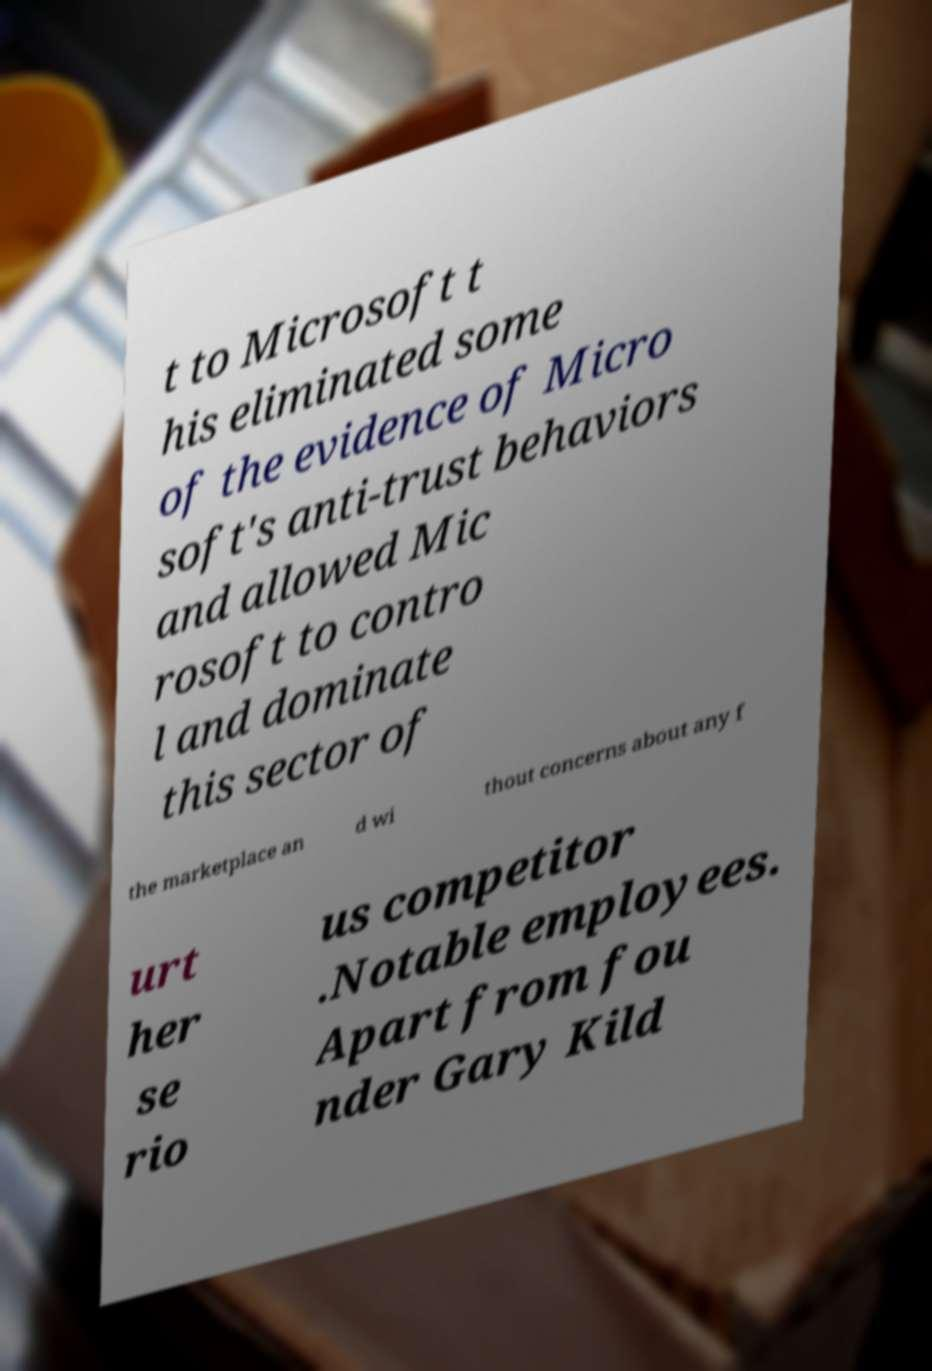Can you read and provide the text displayed in the image?This photo seems to have some interesting text. Can you extract and type it out for me? t to Microsoft t his eliminated some of the evidence of Micro soft's anti-trust behaviors and allowed Mic rosoft to contro l and dominate this sector of the marketplace an d wi thout concerns about any f urt her se rio us competitor .Notable employees. Apart from fou nder Gary Kild 